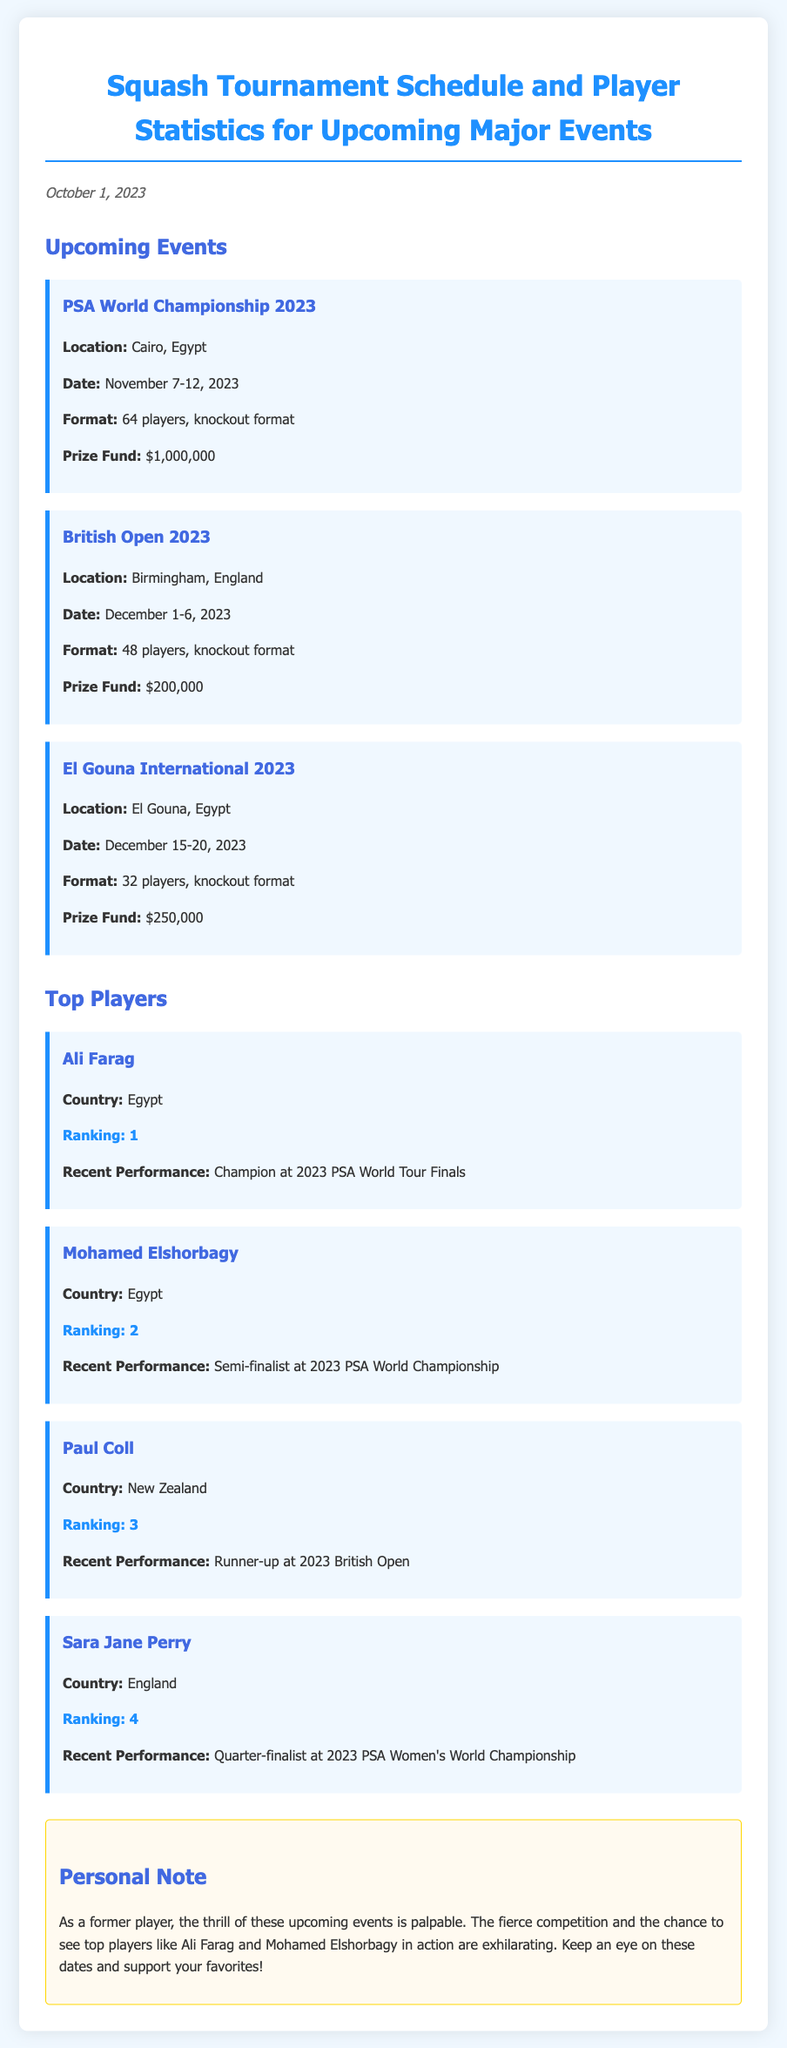What is the location of the PSA World Championship 2023? The document states that the PSA World Championship 2023 is held in Cairo, Egypt.
Answer: Cairo, Egypt What are the dates for the British Open 2023? According to the document, the British Open 2023 is scheduled from December 1 to December 6, 2023.
Answer: December 1-6, 2023 How many players will compete in the El Gouna International 2023? The document mentions that the El Gouna International 2023 will feature 32 players.
Answer: 32 players Who is ranked number 1 in the document? The ranking information provided in the document indicates that Ali Farag is ranked number 1.
Answer: Ali Farag What was Paul Coll's recent performance? The document notes that Paul Coll was the runner-up at the 2023 British Open.
Answer: Runner-up at 2023 British Open What is the prize fund for the PSA World Championship 2023? The document lists the prize fund for the PSA World Championship 2023 as $1,000,000.
Answer: $1,000,000 Which player reached the quarter-finals at the 2023 PSA Women's World Championship? According to the document, Sara Jane Perry reached the quarter-finals at the 2023 PSA Women's World Championship.
Answer: Sara Jane Perry What is the overall theme of the personal note in the document? The personal note expresses excitement and nostalgia about the upcoming events and encourages support for the players.
Answer: Excitement and nostalgia How many events are listed in the document? The document outlines three upcoming events.
Answer: Three events 